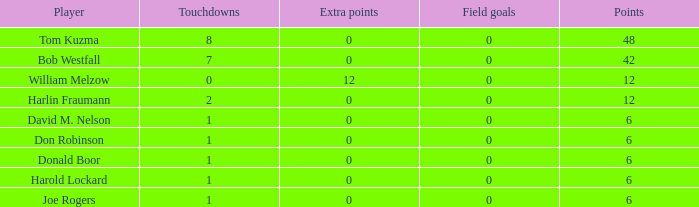List the grades for donald boor. 6.0. 